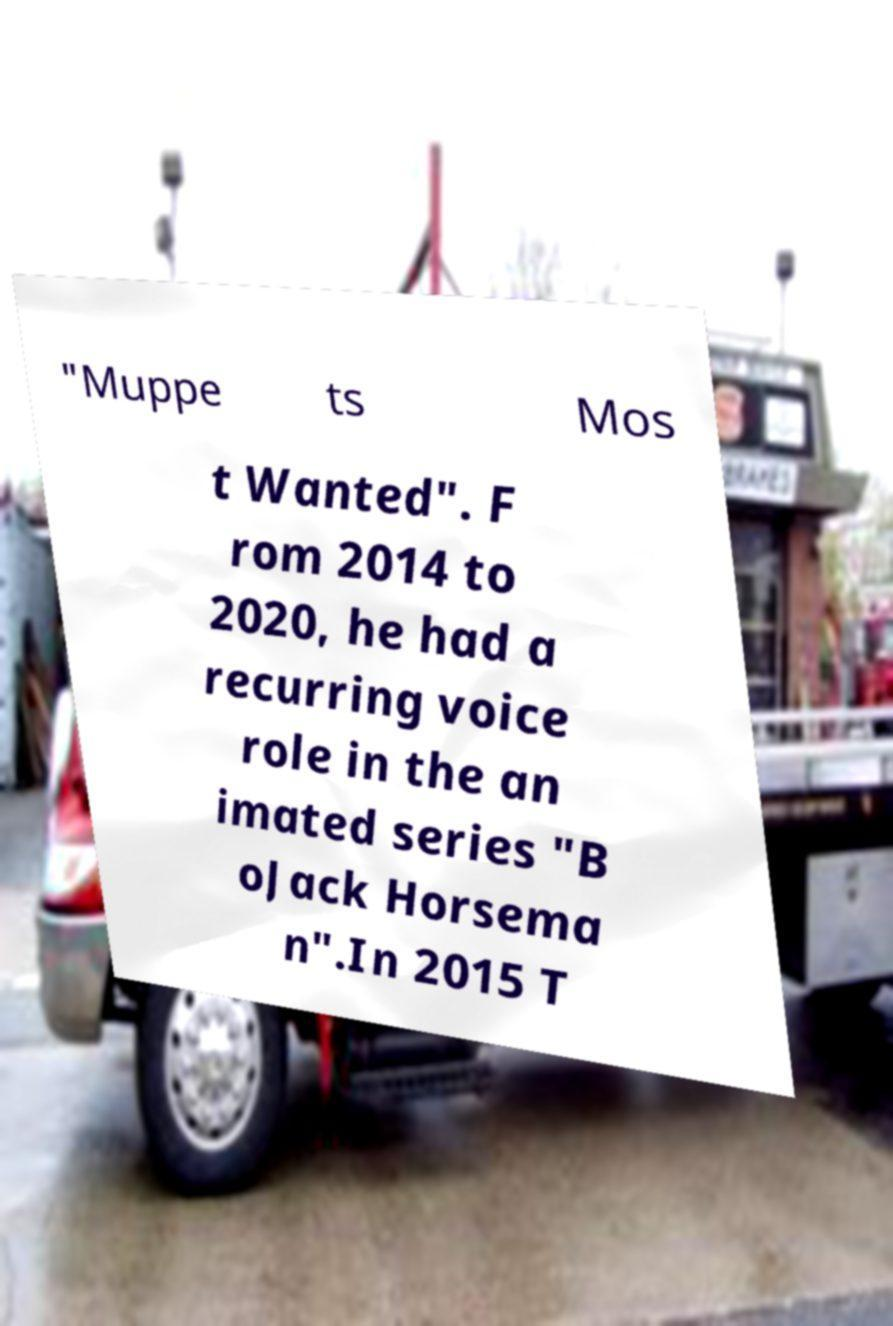Could you assist in decoding the text presented in this image and type it out clearly? "Muppe ts Mos t Wanted". F rom 2014 to 2020, he had a recurring voice role in the an imated series "B oJack Horsema n".In 2015 T 